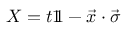<formula> <loc_0><loc_0><loc_500><loc_500>X = t 1 \, 1 - { \vec { x } } \cdot { \vec { \sigma } }</formula> 